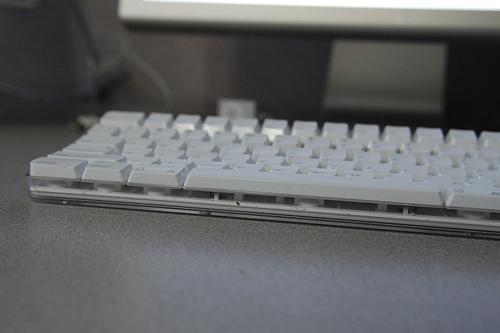Describe the surface where the keyboard is placed. The keyboard is placed on a speckled gray surface of a table or desk. Mention one notable reflection in the image. Light is shining and reflecting off the sides of the keys. What color is the space bar on the keyboard? The space bar is white in color. Estimate the number of objects in the image which are associated with the computer. At least six objects which include keyboard, table, monitor, stand, cords, and wires. What item can be seen just below the computer monitor in the image? White computer keyboard resting on a grey table Briefly describe the scene in the image with the primary focus on the objects. A white computer keyboard with raised keys is placed on a grey table top, under a monitor with a silver stand, and surrounded by blurry wires in the background. Remark on the visibility of the keys on the keyboard. The individual raised keys on the white keyboard are visibly clear with grey letters and numbers. Enumerate any visible interaction between two objects in the image. White computer keyboard on top of a grey table and white bottom of a computer monitor with grey table top. What is the overall mood or sentiment conveyed by the image? Neutral, as it depicts a regular workspace with a keyboard on a table and a computer monitor. Identify the type of computer device present in the picture. A white computer keyboard Is there a round mouse beside the keyboard? No, it's not mentioned in the image. Does the computer monitor have a large blue logo on the bottom edge? While there is a "bottom edge of computer screen" and "white bottom of computer monitor" mentioned, there is no mention of a logo, let alone a large blue one. 